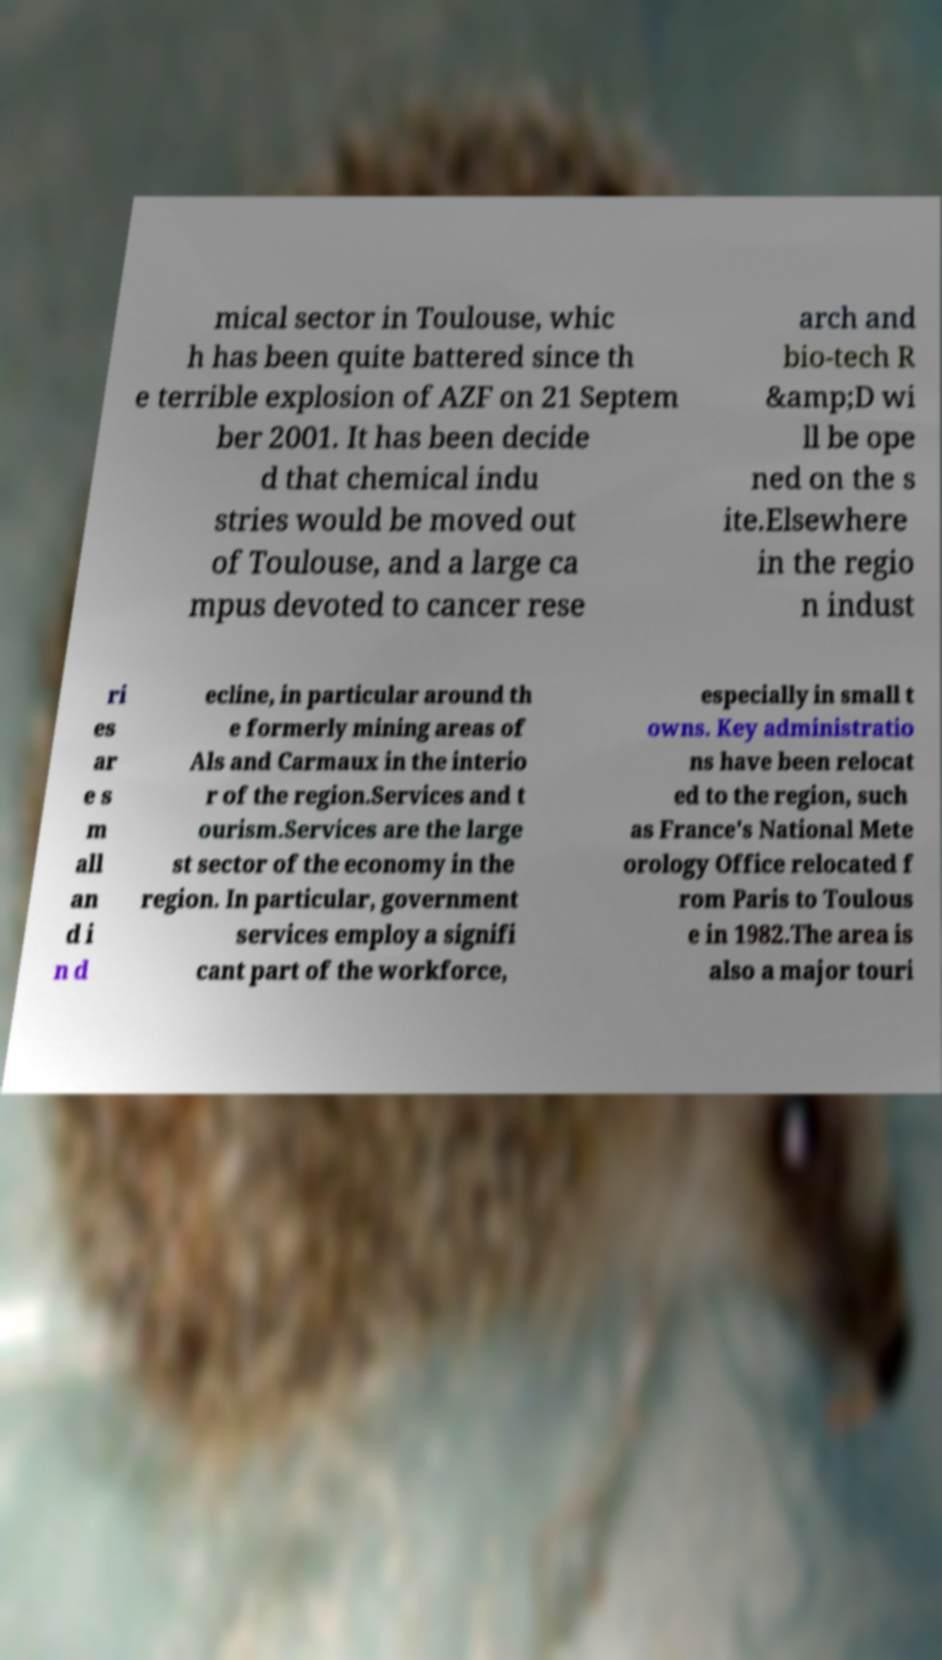Please read and relay the text visible in this image. What does it say? mical sector in Toulouse, whic h has been quite battered since th e terrible explosion of AZF on 21 Septem ber 2001. It has been decide d that chemical indu stries would be moved out of Toulouse, and a large ca mpus devoted to cancer rese arch and bio-tech R &amp;D wi ll be ope ned on the s ite.Elsewhere in the regio n indust ri es ar e s m all an d i n d ecline, in particular around th e formerly mining areas of Als and Carmaux in the interio r of the region.Services and t ourism.Services are the large st sector of the economy in the region. In particular, government services employ a signifi cant part of the workforce, especially in small t owns. Key administratio ns have been relocat ed to the region, such as France's National Mete orology Office relocated f rom Paris to Toulous e in 1982.The area is also a major touri 